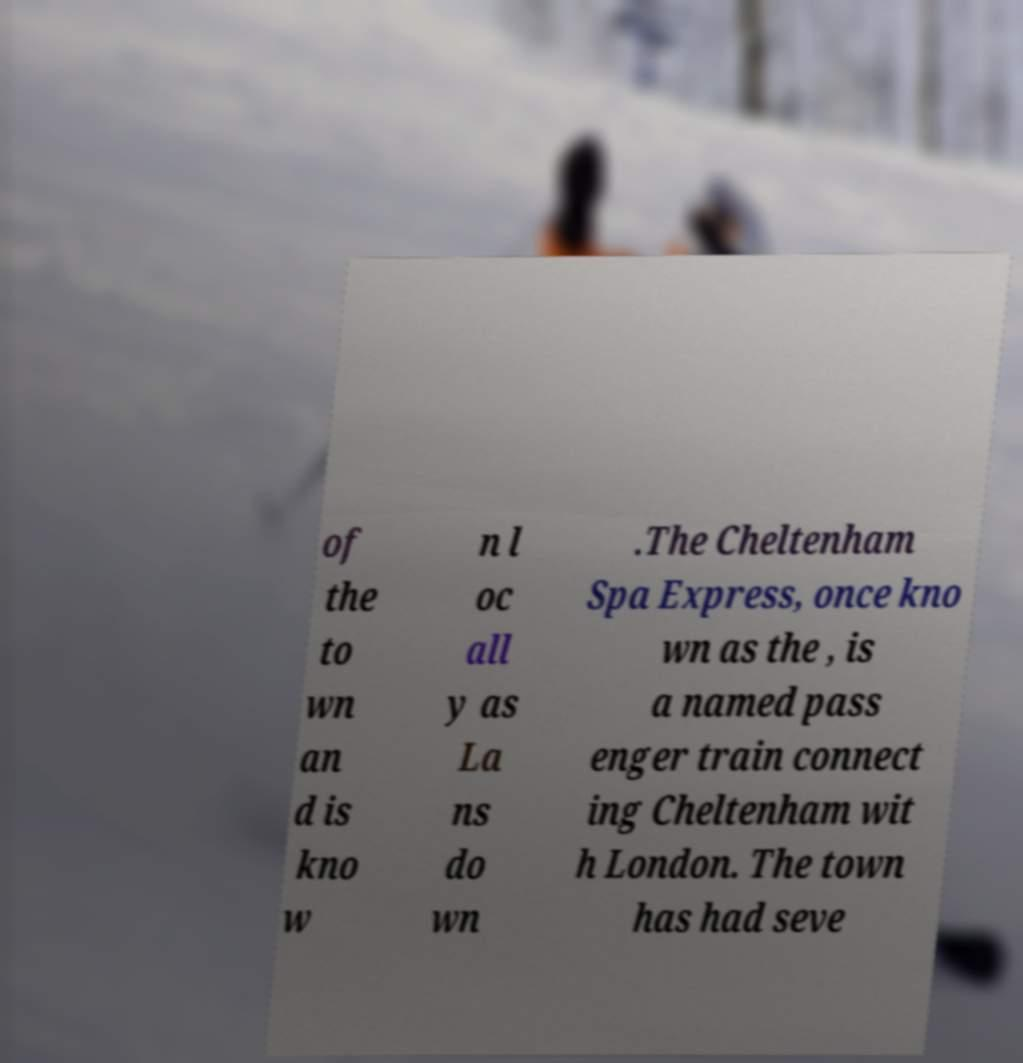What messages or text are displayed in this image? I need them in a readable, typed format. of the to wn an d is kno w n l oc all y as La ns do wn .The Cheltenham Spa Express, once kno wn as the , is a named pass enger train connect ing Cheltenham wit h London. The town has had seve 